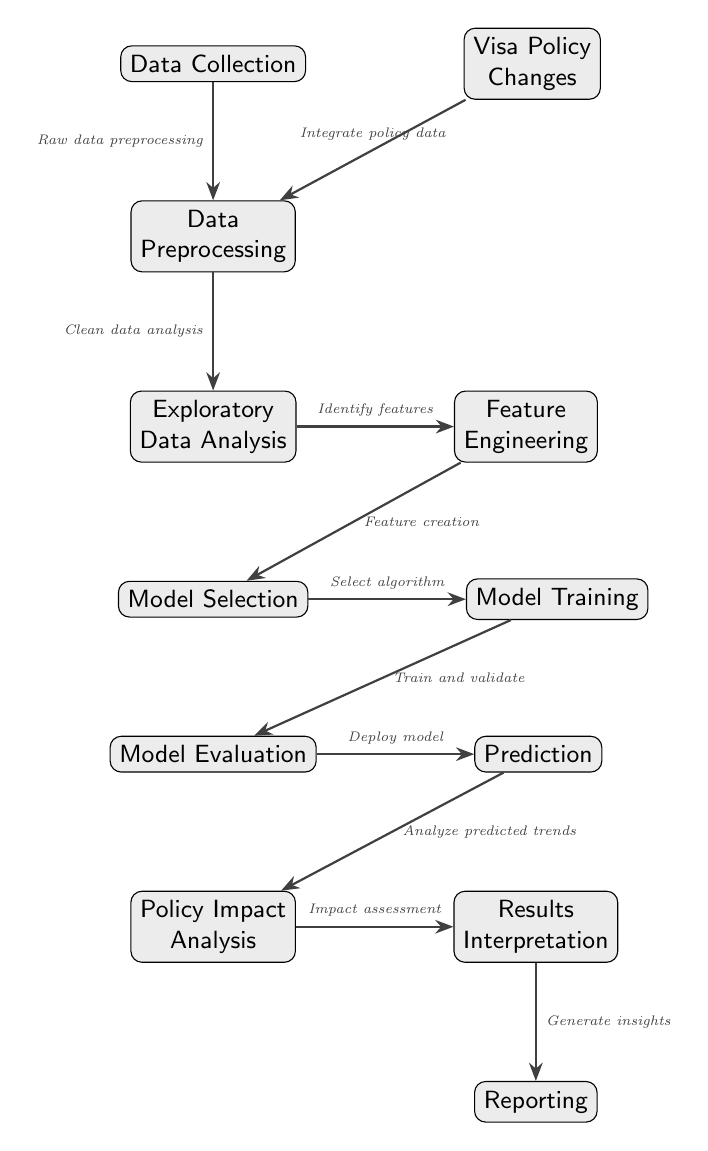What is the first step in the diagram? The first node in the diagram is "Data Collection," which indicates that data must be gathered as the initial step of the process.
Answer: Data Collection How many nodes are there in total? Counting all the distinct nodes in the diagram, there are 11 nodes that represent different stages of the predictive modeling process.
Answer: 11 What type of analysis is conducted after model evaluation? Following the "Model Evaluation" node, the next step is the "Prediction," which means that predictions are generated based on the model's evaluation.
Answer: Prediction What connects data collection and preprocessing? The arrow connecting "Data Collection" and "Data Preprocessing" indicates that raw data is preprocessed, illustrating the direct flow between these steps.
Answer: Raw data preprocessing Which step involves assessing the impact of policy changes? The step titled "Policy Impact Analysis" specifically focuses on evaluating how the predicted trends relate to the changes in visa policy, linking it to the overall study's purpose.
Answer: Policy Impact Analysis What is the output of the "Policy Impact Analysis" step? The output of "Policy Impact Analysis" is directed to the "Results Interpretation" step, which implies that interpretations are drawn from the analysis of policy impacts.
Answer: Results Interpretation What process comes before "Model Selection"? The diagram shows that the "Exploratory Data Analysis" step precedes "Model Selection," allowing for the identification of features that can be important for model selection.
Answer: Exploratory Data Analysis What is the relationship between Feature Engineering and Model Selection? The relationship is that "Feature Engineering" contributes to "Model Selection" by creating features that can be utilized when selecting a suitable algorithm for the predictive model.
Answer: Feature creation Which step involves generating insights? The last step is "Reporting," which involves generating insights based on the results interpretation of the analysis, providing feedback or recommendations.
Answer: Reporting 